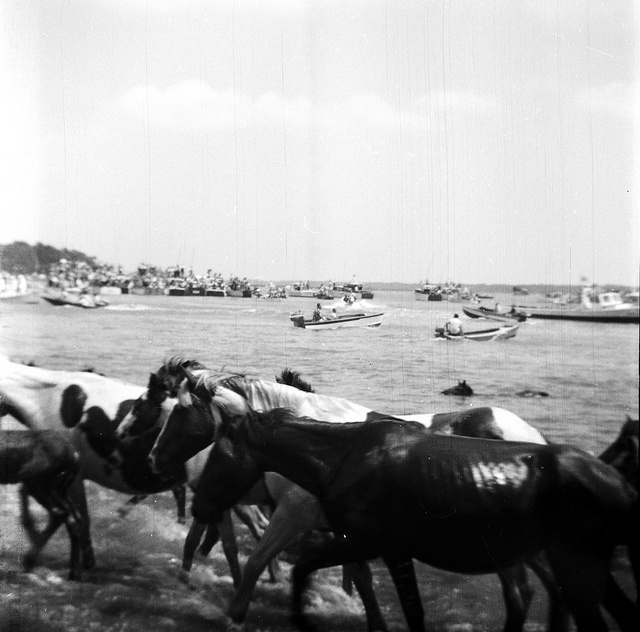Describe the objects in this image and their specific colors. I can see horse in white, black, gray, darkgray, and lightgray tones, horse in white, black, gray, and darkgray tones, horse in white, black, darkgray, and gray tones, horse in white, black, gray, darkgray, and lightgray tones, and horse in white, black, gray, darkgray, and lightgray tones in this image. 